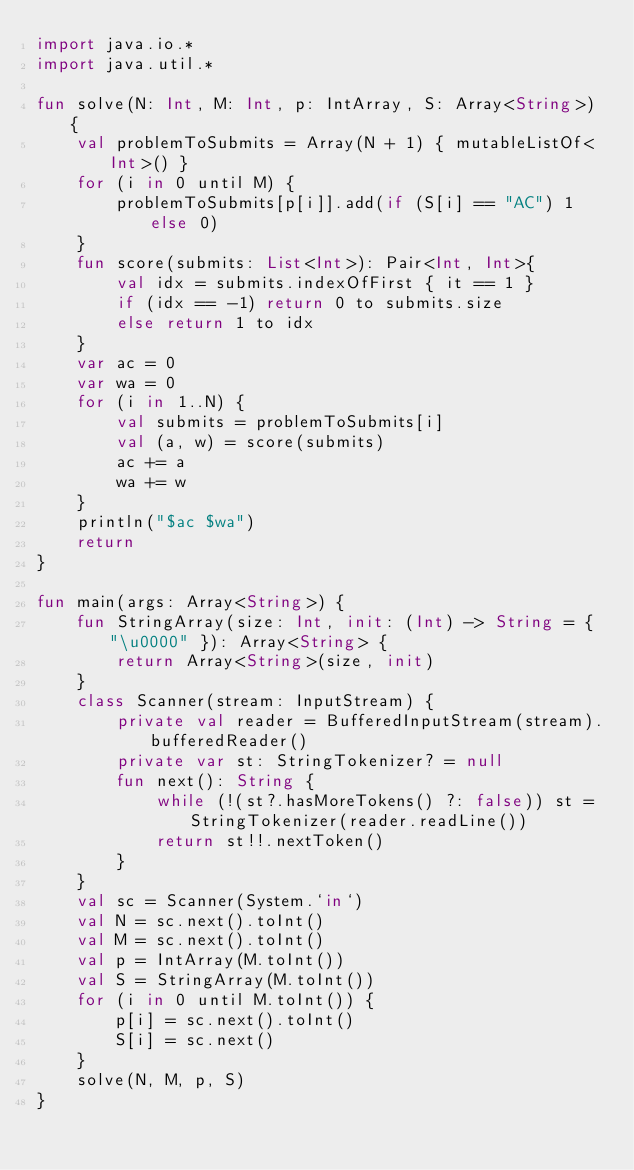<code> <loc_0><loc_0><loc_500><loc_500><_Kotlin_>import java.io.*
import java.util.*

fun solve(N: Int, M: Int, p: IntArray, S: Array<String>) {
    val problemToSubmits = Array(N + 1) { mutableListOf<Int>() }
    for (i in 0 until M) {
        problemToSubmits[p[i]].add(if (S[i] == "AC") 1 else 0)
    }
    fun score(submits: List<Int>): Pair<Int, Int>{
        val idx = submits.indexOfFirst { it == 1 }
        if (idx == -1) return 0 to submits.size
        else return 1 to idx
    }
    var ac = 0
    var wa = 0
    for (i in 1..N) {
        val submits = problemToSubmits[i]
        val (a, w) = score(submits)
        ac += a
        wa += w
    }
    println("$ac $wa")
    return
}

fun main(args: Array<String>) {
    fun StringArray(size: Int, init: (Int) -> String = { "\u0000" }): Array<String> {
        return Array<String>(size, init)
    }
    class Scanner(stream: InputStream) {
        private val reader = BufferedInputStream(stream).bufferedReader()
        private var st: StringTokenizer? = null
        fun next(): String {
            while (!(st?.hasMoreTokens() ?: false)) st = StringTokenizer(reader.readLine())
            return st!!.nextToken()
        }
    }
    val sc = Scanner(System.`in`)
    val N = sc.next().toInt()
    val M = sc.next().toInt()
    val p = IntArray(M.toInt())
    val S = StringArray(M.toInt())
    for (i in 0 until M.toInt()) {
        p[i] = sc.next().toInt()
        S[i] = sc.next()
    }
    solve(N, M, p, S)
}
</code> 